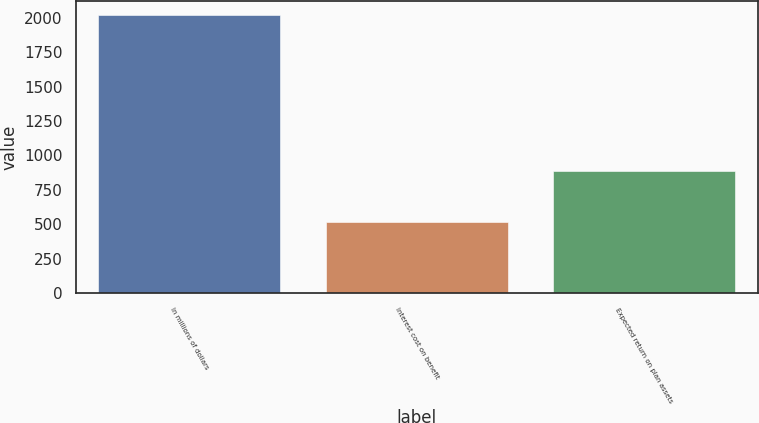<chart> <loc_0><loc_0><loc_500><loc_500><bar_chart><fcel>In millions of dollars<fcel>Interest cost on benefit<fcel>Expected return on plan assets<nl><fcel>2016<fcel>520<fcel>886<nl></chart> 